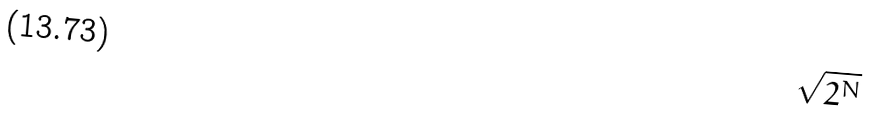<formula> <loc_0><loc_0><loc_500><loc_500>\sqrt { 2 ^ { N } }</formula> 